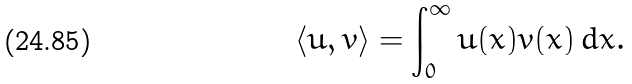<formula> <loc_0><loc_0><loc_500><loc_500>\langle u , v \rangle = \int _ { 0 } ^ { \infty } u ( x ) v ( x ) \, d x .</formula> 